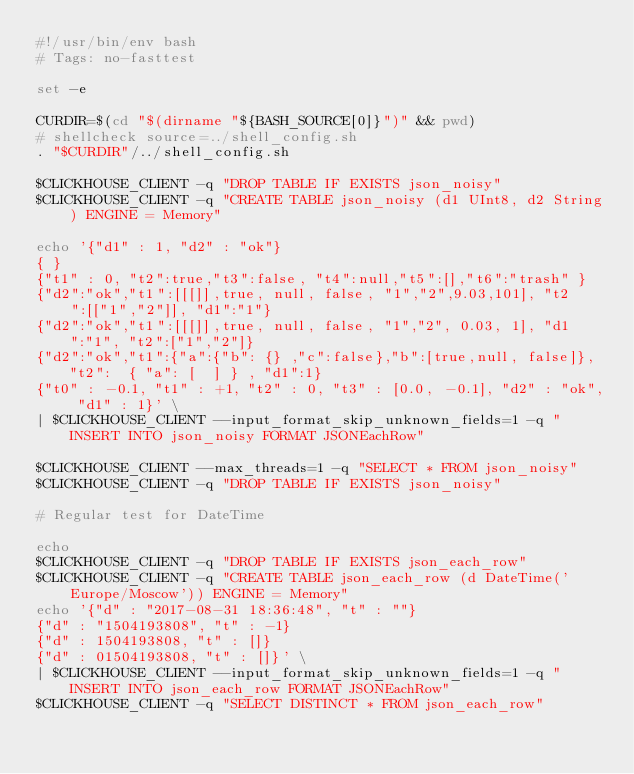<code> <loc_0><loc_0><loc_500><loc_500><_Bash_>#!/usr/bin/env bash
# Tags: no-fasttest

set -e

CURDIR=$(cd "$(dirname "${BASH_SOURCE[0]}")" && pwd)
# shellcheck source=../shell_config.sh
. "$CURDIR"/../shell_config.sh

$CLICKHOUSE_CLIENT -q "DROP TABLE IF EXISTS json_noisy"
$CLICKHOUSE_CLIENT -q "CREATE TABLE json_noisy (d1 UInt8, d2 String) ENGINE = Memory"

echo '{"d1" : 1, "d2" : "ok"}
{ }
{"t1" : 0, "t2":true,"t3":false, "t4":null,"t5":[],"t6":"trash" }
{"d2":"ok","t1":[[[]],true, null, false, "1","2",9.03,101], "t2":[["1","2"]], "d1":"1"}
{"d2":"ok","t1":[[[]],true, null, false, "1","2", 0.03, 1], "d1":"1", "t2":["1","2"]}
{"d2":"ok","t1":{"a":{"b": {} ,"c":false},"b":[true,null, false]}, "t2":  { "a": [  ] } , "d1":1}
{"t0" : -0.1, "t1" : +1, "t2" : 0, "t3" : [0.0, -0.1], "d2" : "ok", "d1" : 1}' \
| $CLICKHOUSE_CLIENT --input_format_skip_unknown_fields=1 -q "INSERT INTO json_noisy FORMAT JSONEachRow"

$CLICKHOUSE_CLIENT --max_threads=1 -q "SELECT * FROM json_noisy"
$CLICKHOUSE_CLIENT -q "DROP TABLE IF EXISTS json_noisy"

# Regular test for DateTime

echo
$CLICKHOUSE_CLIENT -q "DROP TABLE IF EXISTS json_each_row"
$CLICKHOUSE_CLIENT -q "CREATE TABLE json_each_row (d DateTime('Europe/Moscow')) ENGINE = Memory"
echo '{"d" : "2017-08-31 18:36:48", "t" : ""}
{"d" : "1504193808", "t" : -1}
{"d" : 1504193808, "t" : []}
{"d" : 01504193808, "t" : []}' \
| $CLICKHOUSE_CLIENT --input_format_skip_unknown_fields=1 -q "INSERT INTO json_each_row FORMAT JSONEachRow"
$CLICKHOUSE_CLIENT -q "SELECT DISTINCT * FROM json_each_row"</code> 